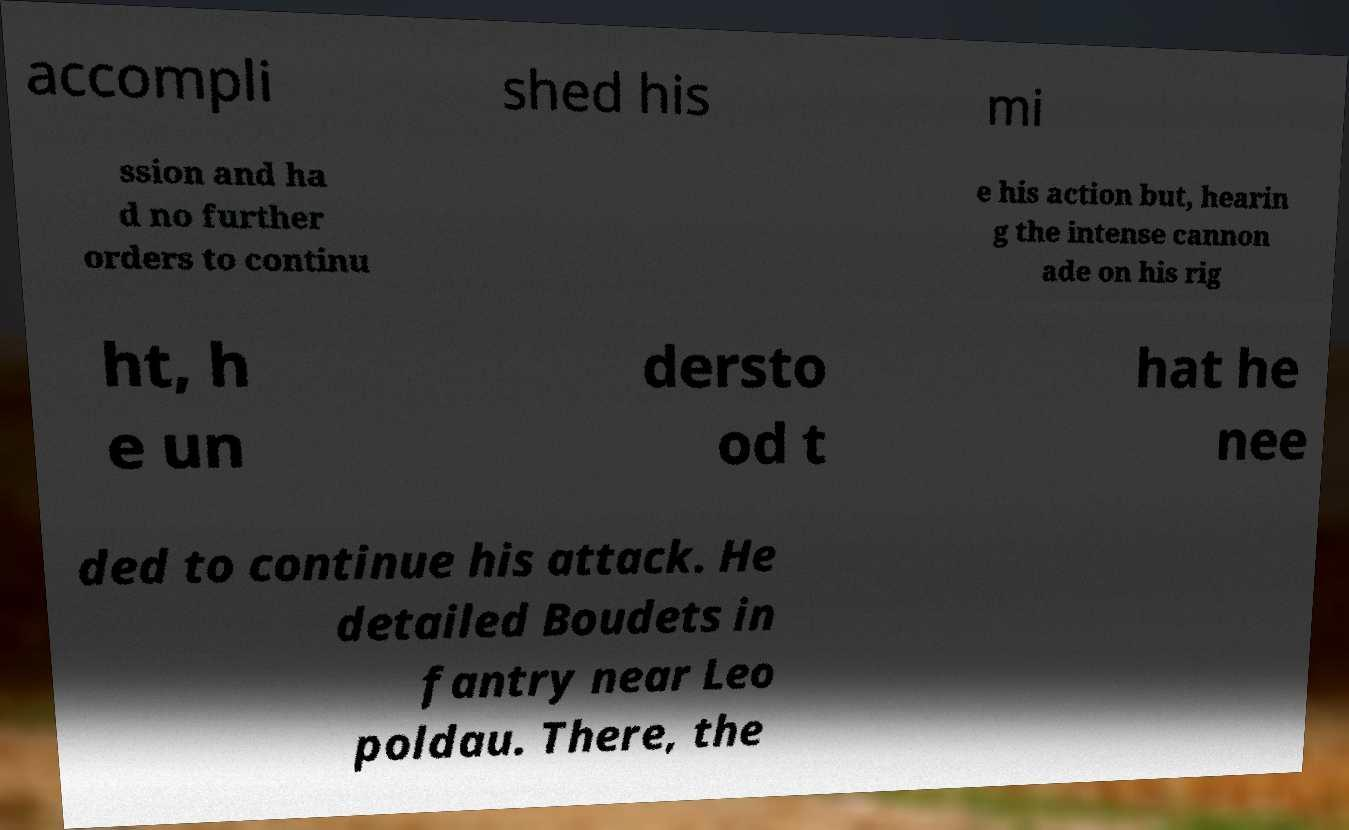There's text embedded in this image that I need extracted. Can you transcribe it verbatim? accompli shed his mi ssion and ha d no further orders to continu e his action but, hearin g the intense cannon ade on his rig ht, h e un dersto od t hat he nee ded to continue his attack. He detailed Boudets in fantry near Leo poldau. There, the 